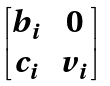<formula> <loc_0><loc_0><loc_500><loc_500>\begin{bmatrix} b _ { i } & 0 \\ c _ { i } & v _ { i } \end{bmatrix}</formula> 